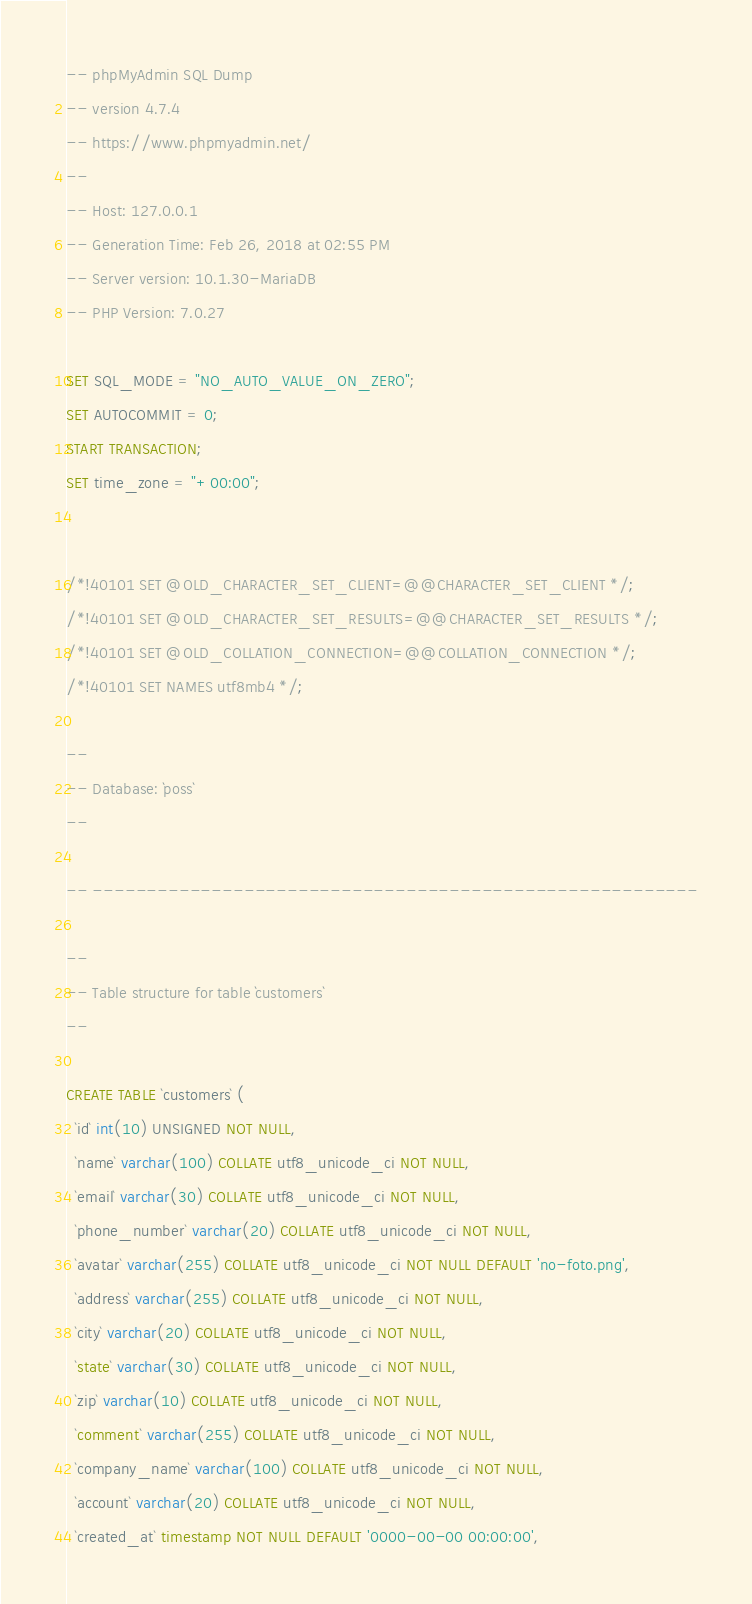Convert code to text. <code><loc_0><loc_0><loc_500><loc_500><_SQL_>-- phpMyAdmin SQL Dump
-- version 4.7.4
-- https://www.phpmyadmin.net/
--
-- Host: 127.0.0.1
-- Generation Time: Feb 26, 2018 at 02:55 PM
-- Server version: 10.1.30-MariaDB
-- PHP Version: 7.0.27

SET SQL_MODE = "NO_AUTO_VALUE_ON_ZERO";
SET AUTOCOMMIT = 0;
START TRANSACTION;
SET time_zone = "+00:00";


/*!40101 SET @OLD_CHARACTER_SET_CLIENT=@@CHARACTER_SET_CLIENT */;
/*!40101 SET @OLD_CHARACTER_SET_RESULTS=@@CHARACTER_SET_RESULTS */;
/*!40101 SET @OLD_COLLATION_CONNECTION=@@COLLATION_CONNECTION */;
/*!40101 SET NAMES utf8mb4 */;

--
-- Database: `poss`
--

-- --------------------------------------------------------

--
-- Table structure for table `customers`
--

CREATE TABLE `customers` (
  `id` int(10) UNSIGNED NOT NULL,
  `name` varchar(100) COLLATE utf8_unicode_ci NOT NULL,
  `email` varchar(30) COLLATE utf8_unicode_ci NOT NULL,
  `phone_number` varchar(20) COLLATE utf8_unicode_ci NOT NULL,
  `avatar` varchar(255) COLLATE utf8_unicode_ci NOT NULL DEFAULT 'no-foto.png',
  `address` varchar(255) COLLATE utf8_unicode_ci NOT NULL,
  `city` varchar(20) COLLATE utf8_unicode_ci NOT NULL,
  `state` varchar(30) COLLATE utf8_unicode_ci NOT NULL,
  `zip` varchar(10) COLLATE utf8_unicode_ci NOT NULL,
  `comment` varchar(255) COLLATE utf8_unicode_ci NOT NULL,
  `company_name` varchar(100) COLLATE utf8_unicode_ci NOT NULL,
  `account` varchar(20) COLLATE utf8_unicode_ci NOT NULL,
  `created_at` timestamp NOT NULL DEFAULT '0000-00-00 00:00:00',</code> 